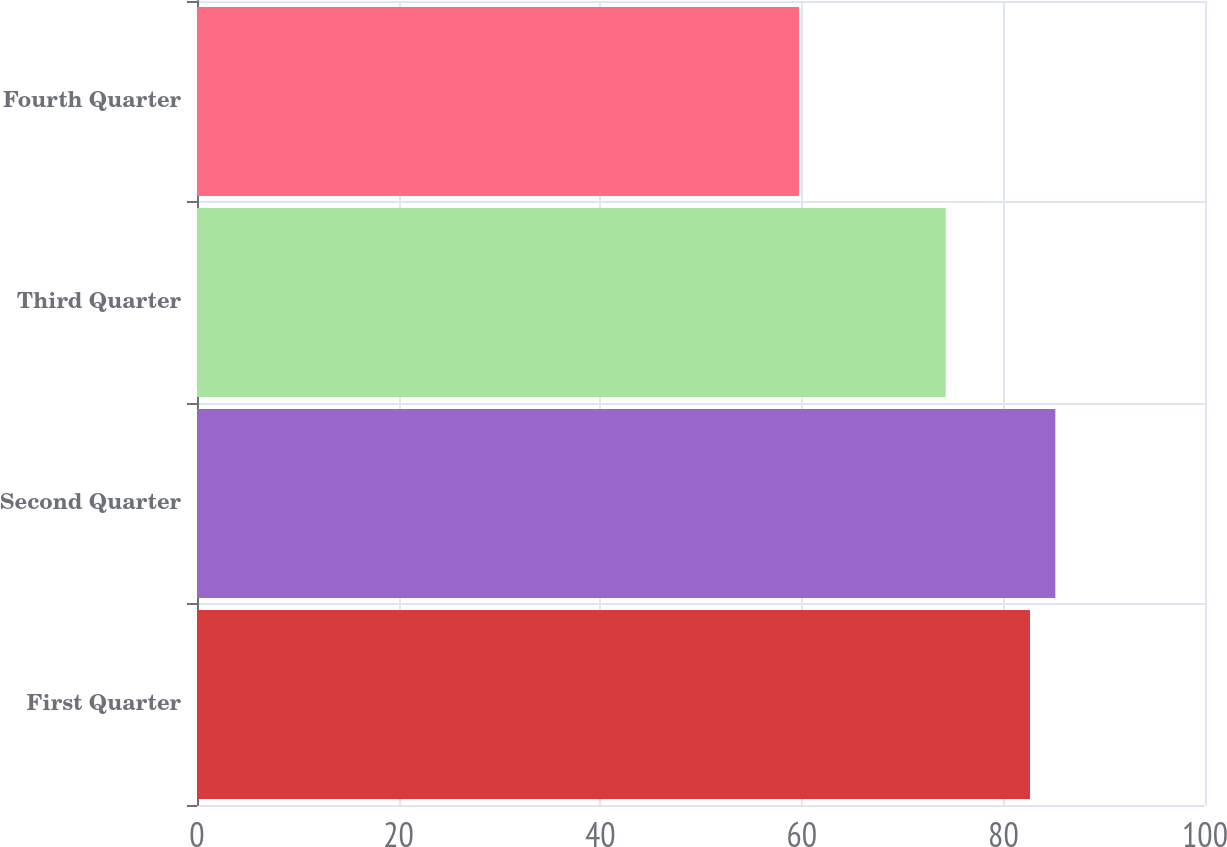<chart> <loc_0><loc_0><loc_500><loc_500><bar_chart><fcel>First Quarter<fcel>Second Quarter<fcel>Third Quarter<fcel>Fourth Quarter<nl><fcel>82.64<fcel>85.15<fcel>74.28<fcel>59.73<nl></chart> 